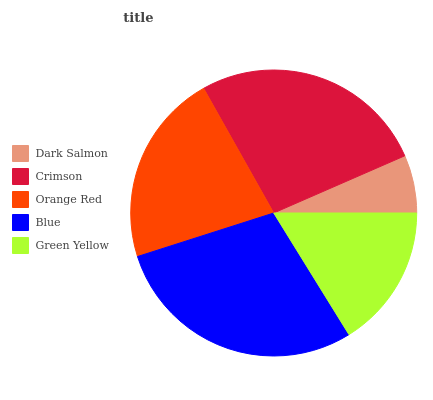Is Dark Salmon the minimum?
Answer yes or no. Yes. Is Blue the maximum?
Answer yes or no. Yes. Is Crimson the minimum?
Answer yes or no. No. Is Crimson the maximum?
Answer yes or no. No. Is Crimson greater than Dark Salmon?
Answer yes or no. Yes. Is Dark Salmon less than Crimson?
Answer yes or no. Yes. Is Dark Salmon greater than Crimson?
Answer yes or no. No. Is Crimson less than Dark Salmon?
Answer yes or no. No. Is Orange Red the high median?
Answer yes or no. Yes. Is Orange Red the low median?
Answer yes or no. Yes. Is Crimson the high median?
Answer yes or no. No. Is Green Yellow the low median?
Answer yes or no. No. 